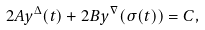<formula> <loc_0><loc_0><loc_500><loc_500>2 A y ^ { \Delta } ( t ) + 2 B y ^ { \nabla } ( \sigma ( t ) ) = C ,</formula> 